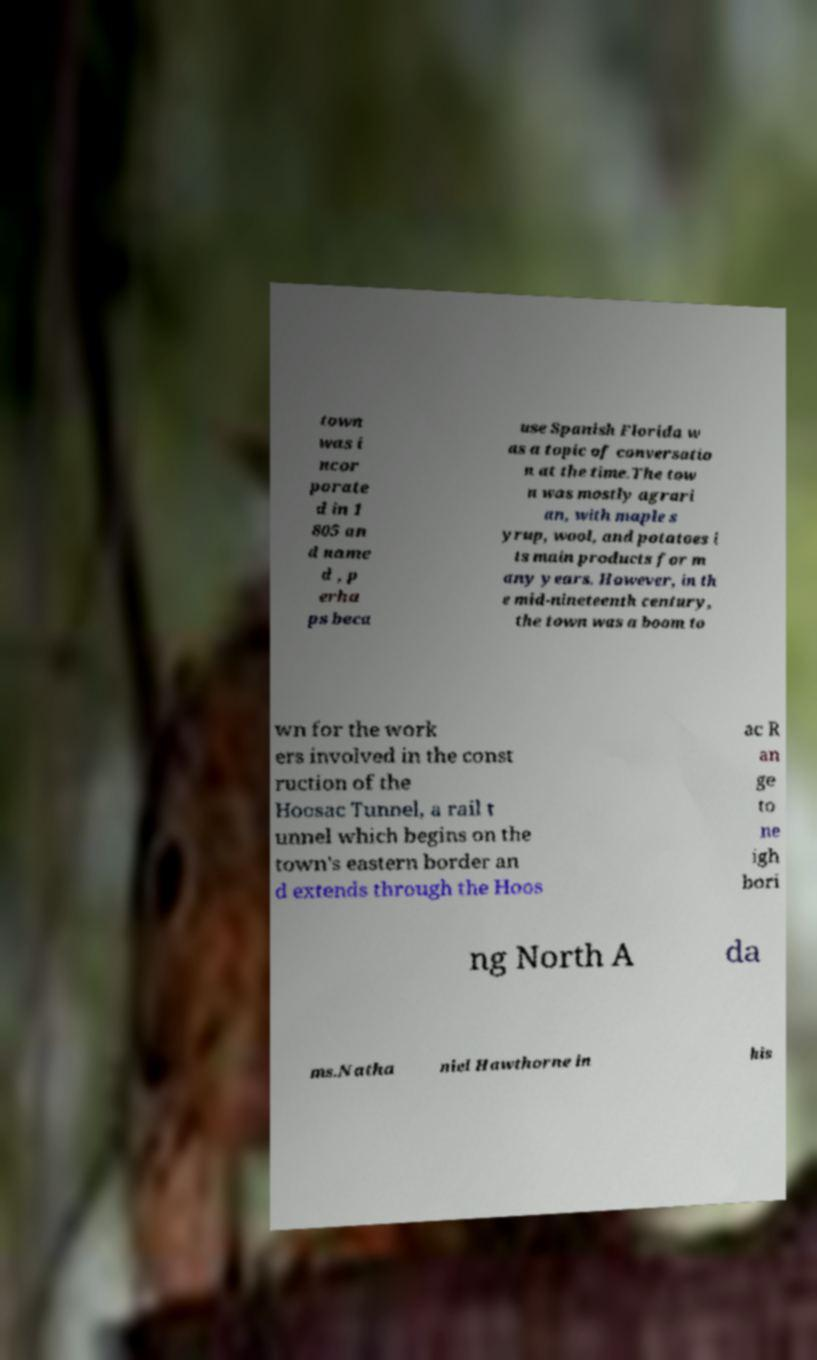What messages or text are displayed in this image? I need them in a readable, typed format. town was i ncor porate d in 1 805 an d name d , p erha ps beca use Spanish Florida w as a topic of conversatio n at the time.The tow n was mostly agrari an, with maple s yrup, wool, and potatoes i ts main products for m any years. However, in th e mid-nineteenth century, the town was a boom to wn for the work ers involved in the const ruction of the Hoosac Tunnel, a rail t unnel which begins on the town's eastern border an d extends through the Hoos ac R an ge to ne igh bori ng North A da ms.Natha niel Hawthorne in his 